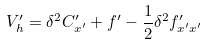Convert formula to latex. <formula><loc_0><loc_0><loc_500><loc_500>V _ { h } ^ { \prime } = \delta ^ { 2 } C ^ { \prime } _ { x ^ { \prime } } + f ^ { \prime } - \frac { 1 } { 2 } \delta ^ { 2 } f ^ { \prime } _ { x ^ { \prime } x ^ { \prime } }</formula> 